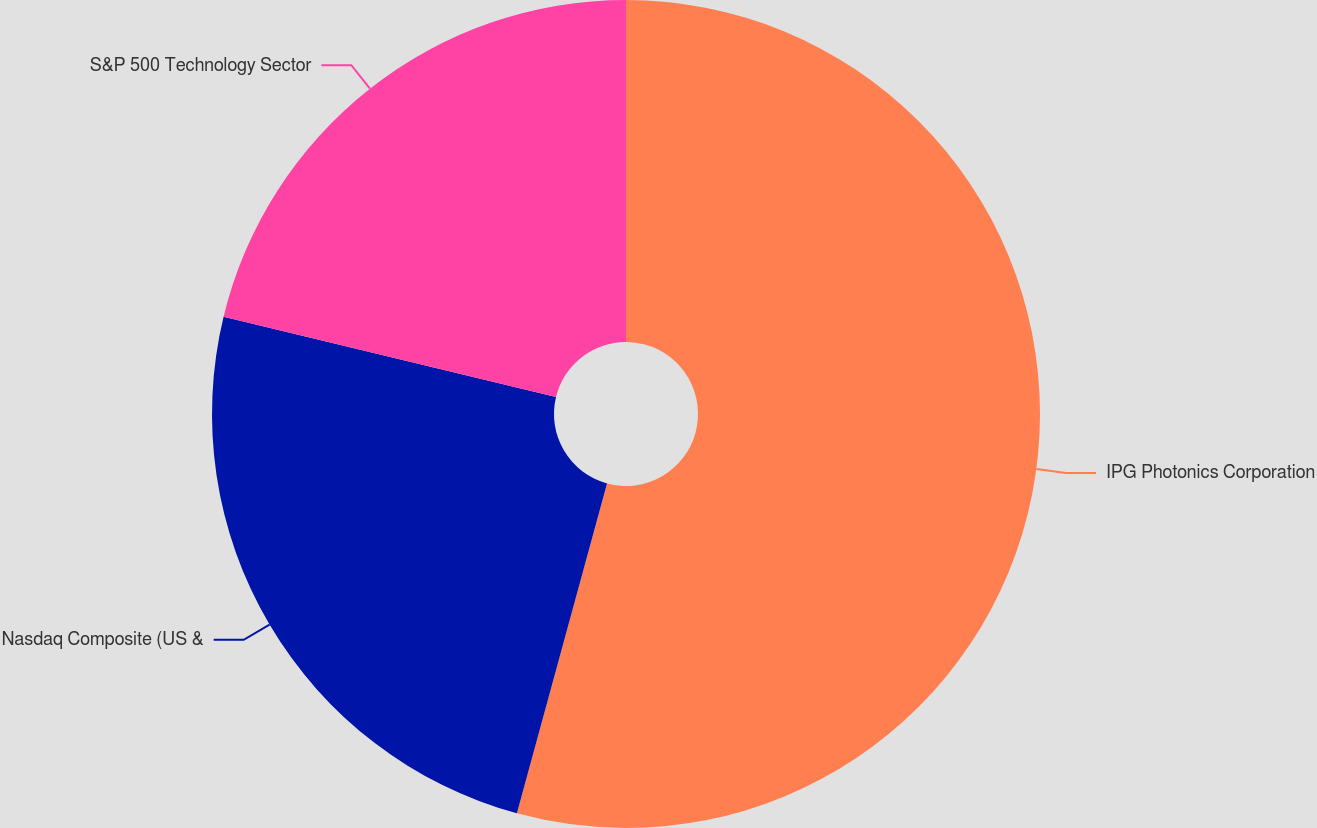Convert chart to OTSL. <chart><loc_0><loc_0><loc_500><loc_500><pie_chart><fcel>IPG Photonics Corporation<fcel>Nasdaq Composite (US &<fcel>S&P 500 Technology Sector<nl><fcel>54.25%<fcel>24.53%<fcel>21.23%<nl></chart> 